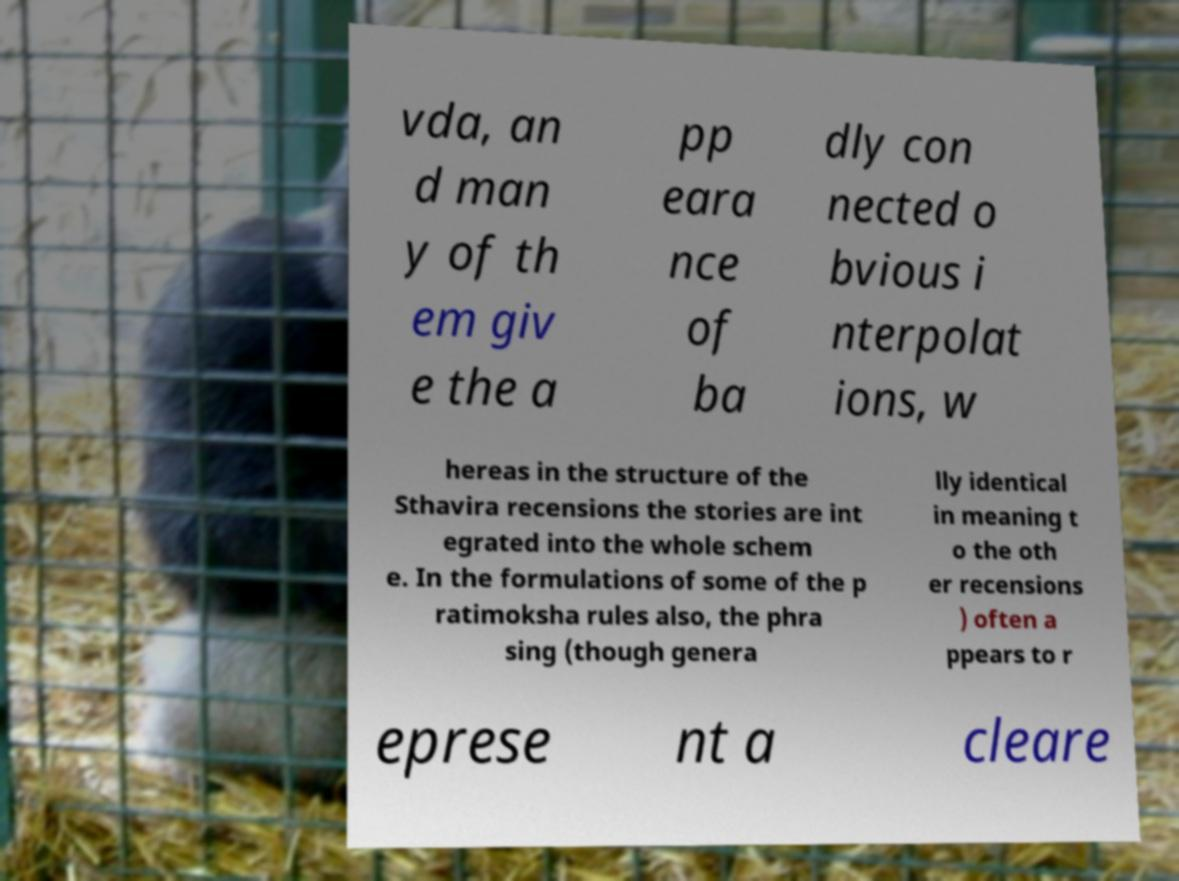There's text embedded in this image that I need extracted. Can you transcribe it verbatim? vda, an d man y of th em giv e the a pp eara nce of ba dly con nected o bvious i nterpolat ions, w hereas in the structure of the Sthavira recensions the stories are int egrated into the whole schem e. In the formulations of some of the p ratimoksha rules also, the phra sing (though genera lly identical in meaning t o the oth er recensions ) often a ppears to r eprese nt a cleare 